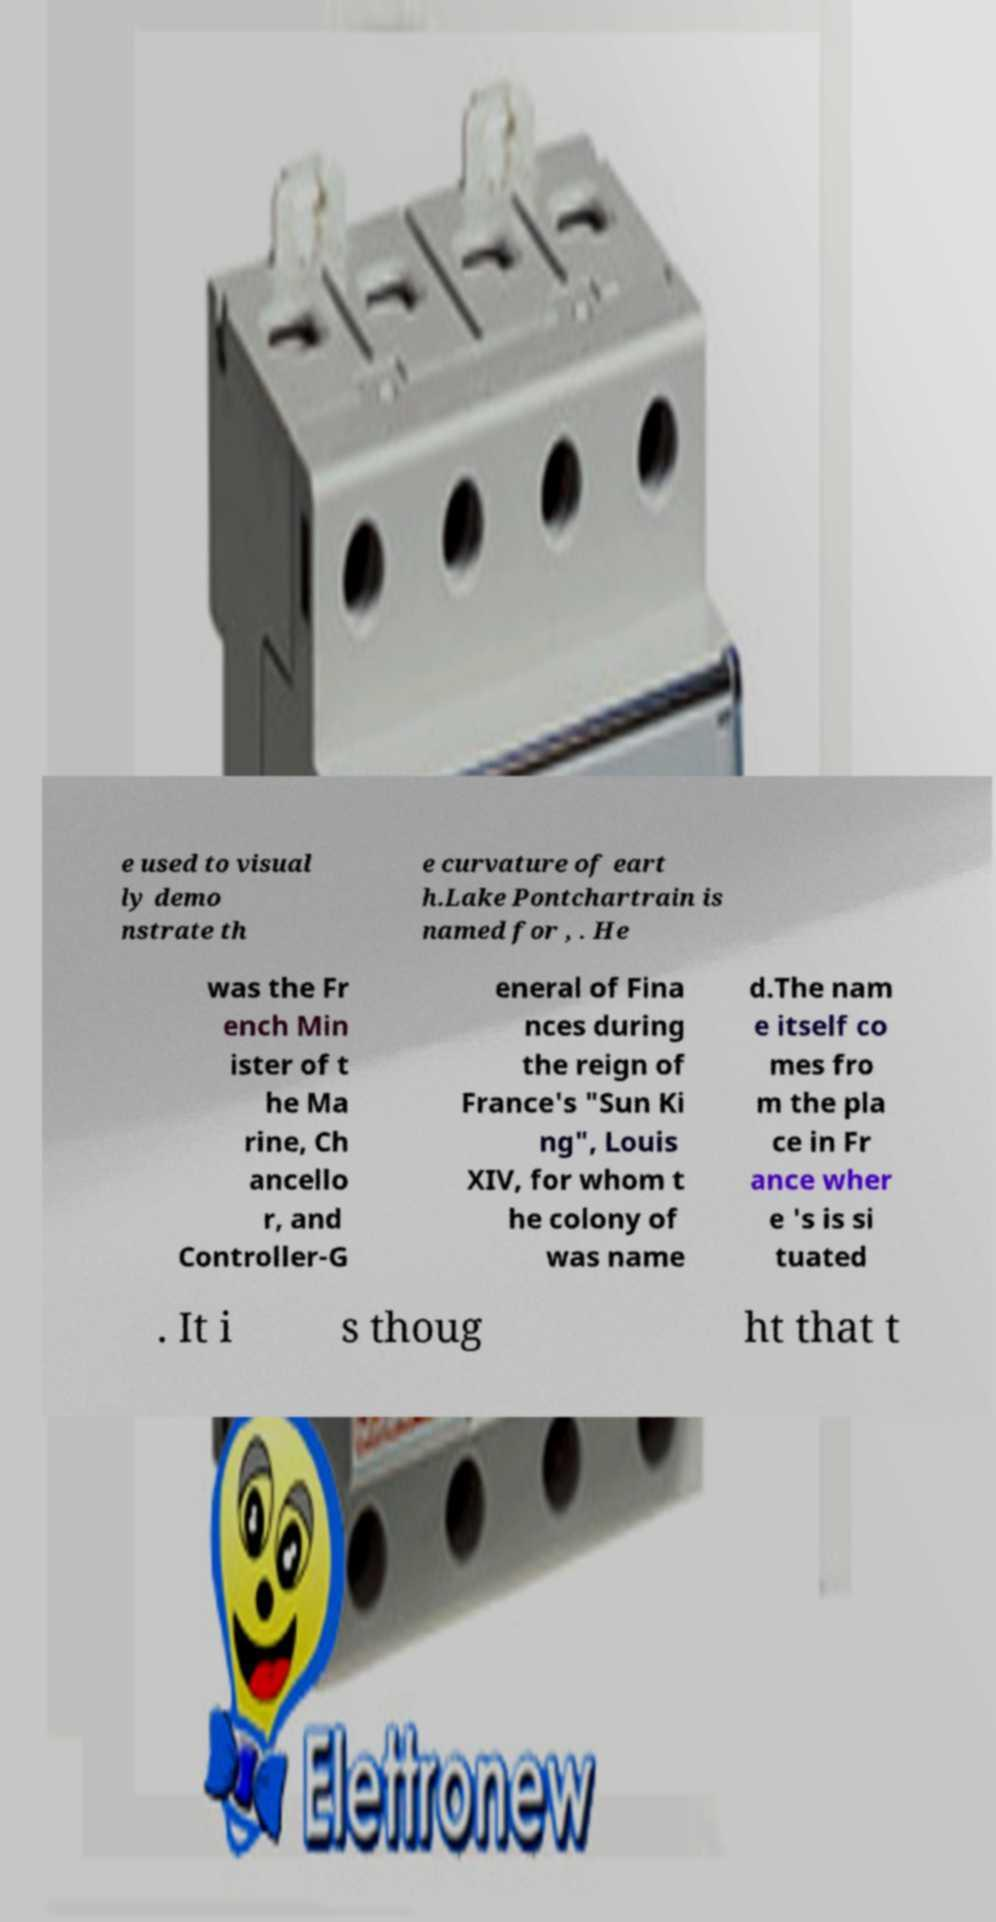Could you extract and type out the text from this image? e used to visual ly demo nstrate th e curvature of eart h.Lake Pontchartrain is named for , . He was the Fr ench Min ister of t he Ma rine, Ch ancello r, and Controller-G eneral of Fina nces during the reign of France's "Sun Ki ng", Louis XIV, for whom t he colony of was name d.The nam e itself co mes fro m the pla ce in Fr ance wher e 's is si tuated . It i s thoug ht that t 